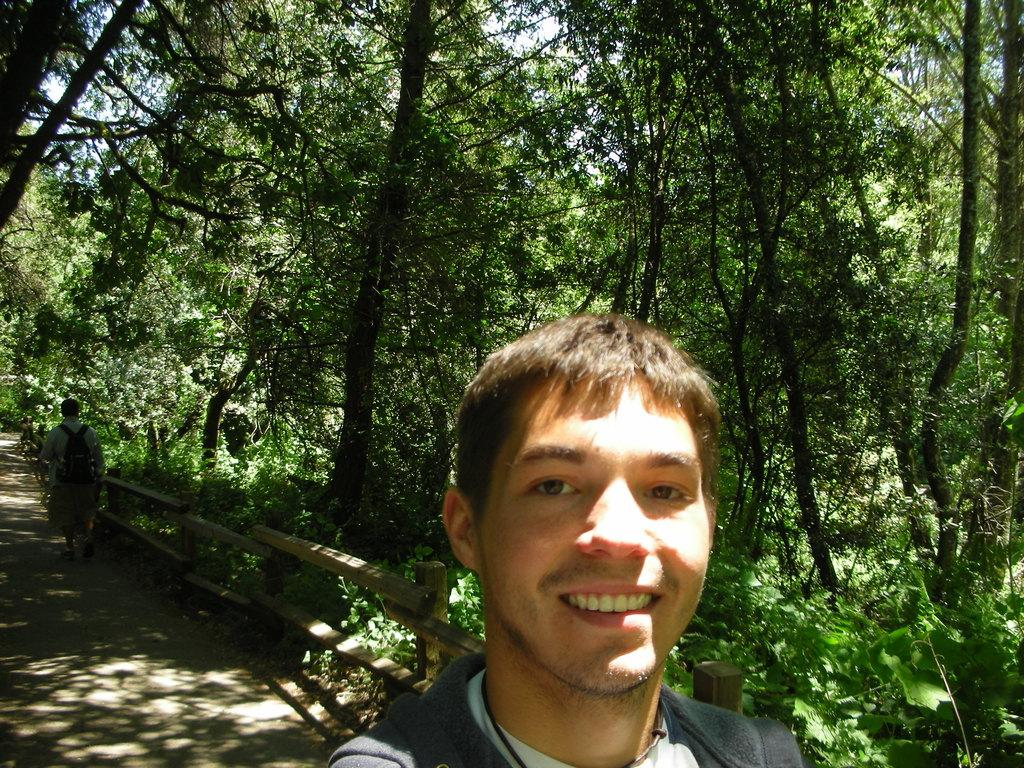How many people are in the image? There are two people in the image. What is one person doing in the image? One person is walking on the road with a backpack. Where is the person walking in relation to the railing? The person is near the railing. What can be seen on the right side of the image? There are trees on the right side of the image. What type of stone is being used as a representative in the image? There is no stone or representative present in the image. How does the sand move around in the image? There is no sand present in the image. 